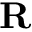Convert formula to latex. <formula><loc_0><loc_0><loc_500><loc_500>R</formula> 